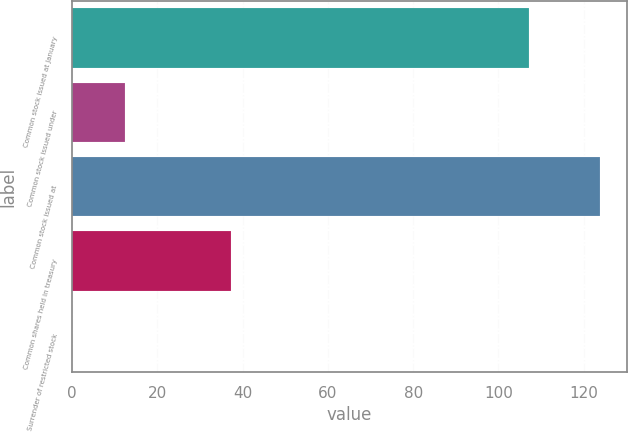Convert chart to OTSL. <chart><loc_0><loc_0><loc_500><loc_500><bar_chart><fcel>Common stock issued at January<fcel>Common stock issued under<fcel>Common stock issued at<fcel>Common shares held in treasury<fcel>Surrender of restricted stock<nl><fcel>107.1<fcel>12.48<fcel>123.9<fcel>37.24<fcel>0.1<nl></chart> 